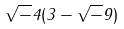<formula> <loc_0><loc_0><loc_500><loc_500>\sqrt { - } 4 ( 3 - \sqrt { - } 9 )</formula> 